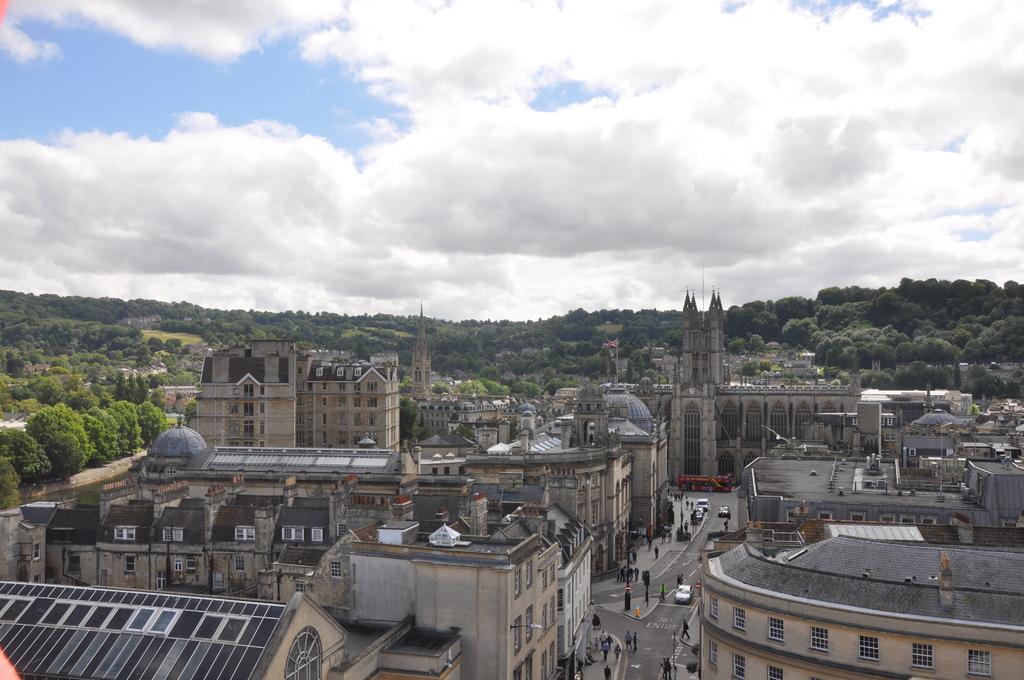How would you summarize this image in a sentence or two? This is the aerial view of a city. At the top of the image we can see sky with clouds, trees, hills and flag with flag post. At the bottom of the image we can see buildings, castles, roads, motor vehicles, persons, street poles, street lights and tombs. 